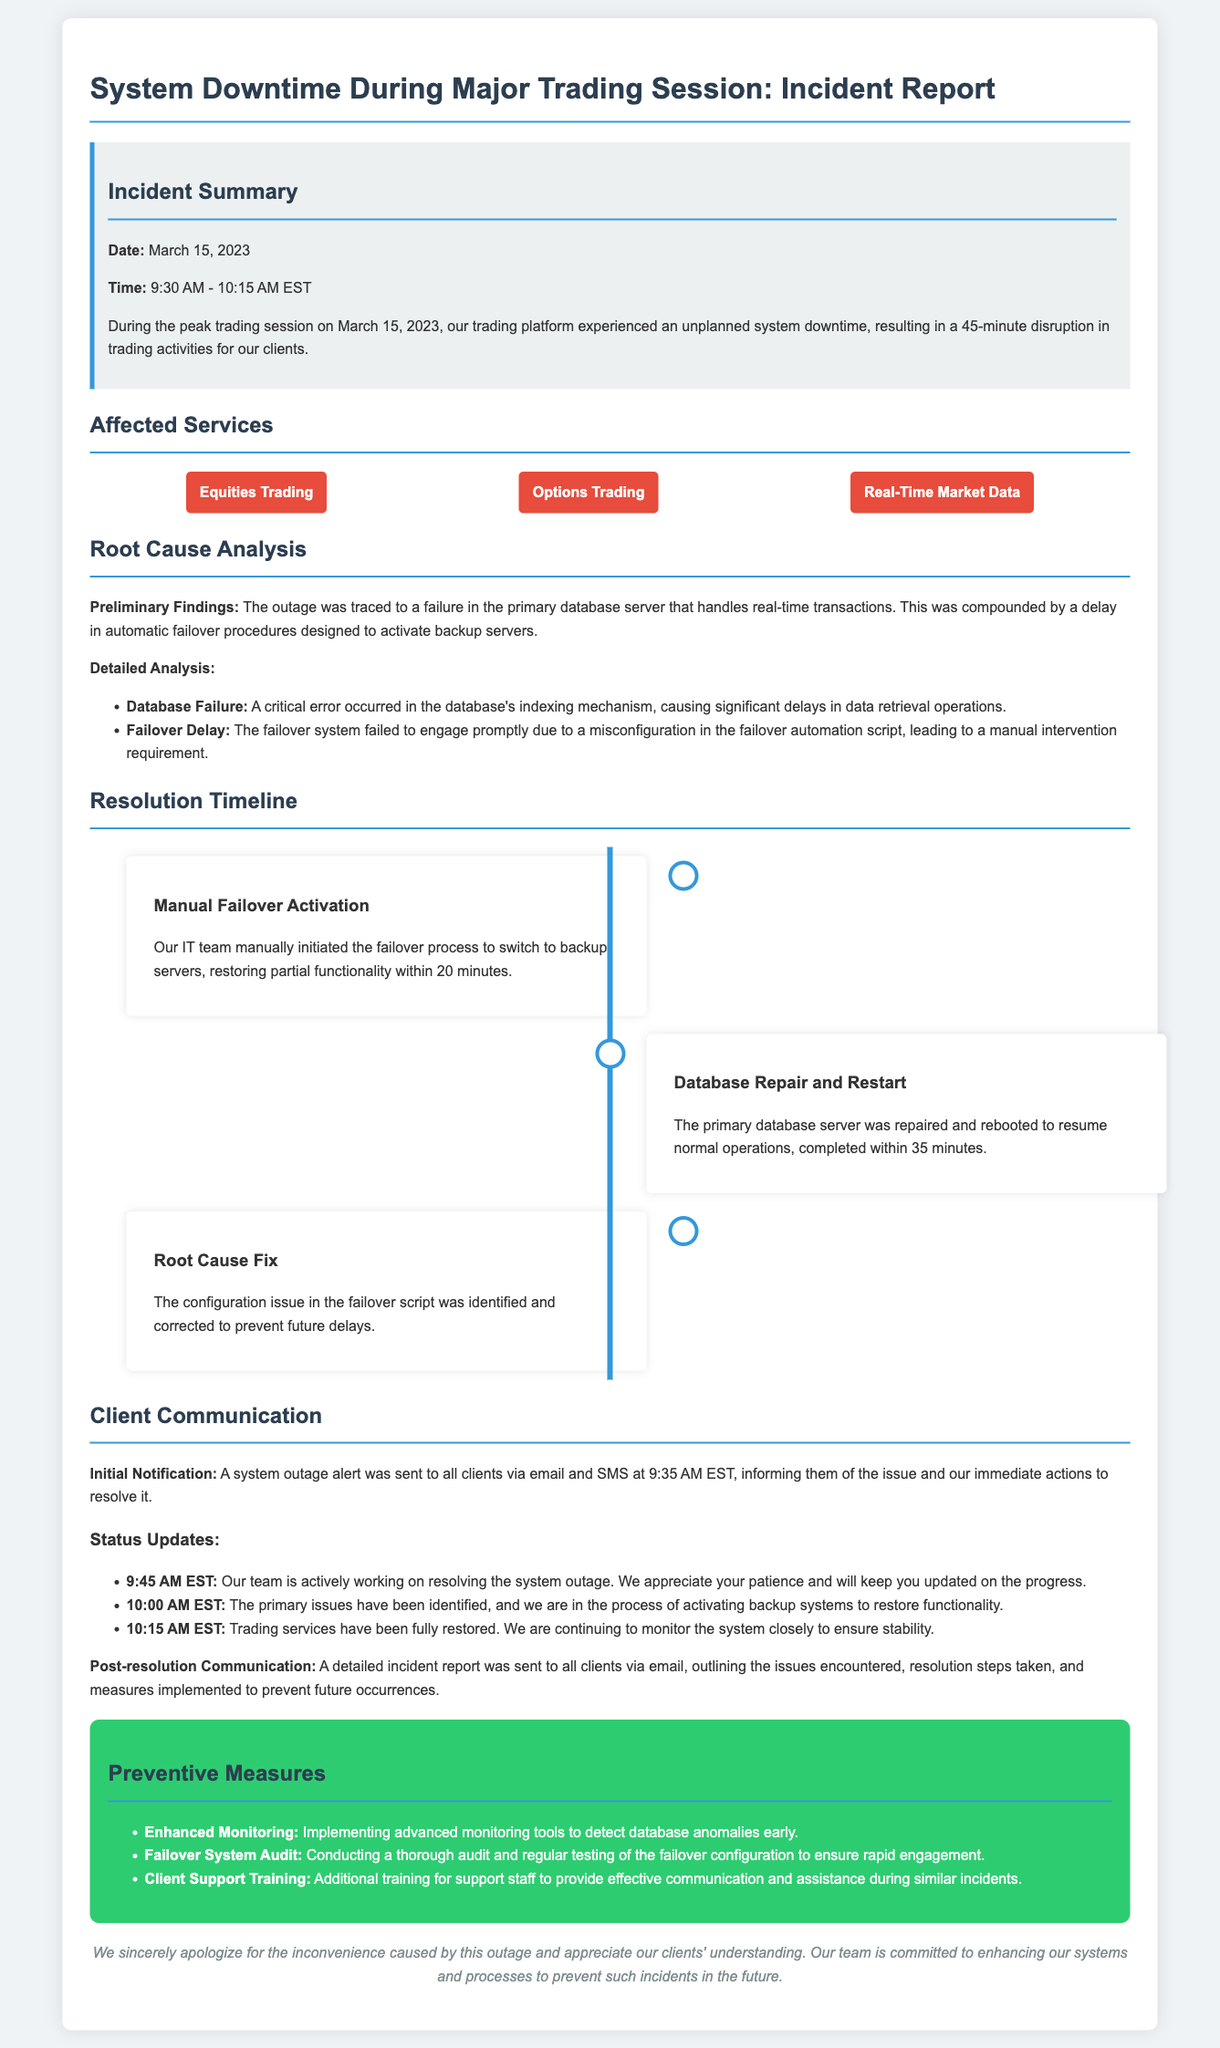What was the date of the incident? The incident occurred on March 15, 2023, as stated in the incident summary.
Answer: March 15, 2023 What was the duration of the downtime? The downtime lasted for 45 minutes, as mentioned in the summary of the incident.
Answer: 45 minutes What services were affected by the outage? The affected services listed include Equities Trading, Options Trading, and Real-Time Market Data.
Answer: Equities Trading, Options Trading, Real-Time Market Data What was the primary cause of the system downtime? The primary cause was a failure in the primary database server.
Answer: Database server failure At what time was the initial notification sent to clients? The initial notification alert was sent at 9:35 AM EST, as noted in the client communication section.
Answer: 9:35 AM EST How long did it take to manually activate the failover? The manual failover activation restored partial functionality within 20 minutes.
Answer: 20 minutes What measure is being implemented to detect database anomalies? Enhanced Monitoring is the preventive measure mentioned in the report.
Answer: Enhanced Monitoring What type of communication was used to notify clients? Clients were notified via email and SMS, as stated in the communication section.
Answer: Email and SMS What was done to ensure rapid engagement of the failover system? A thorough audit and regular testing of the failover configuration will be conducted.
Answer: Failover system audit 